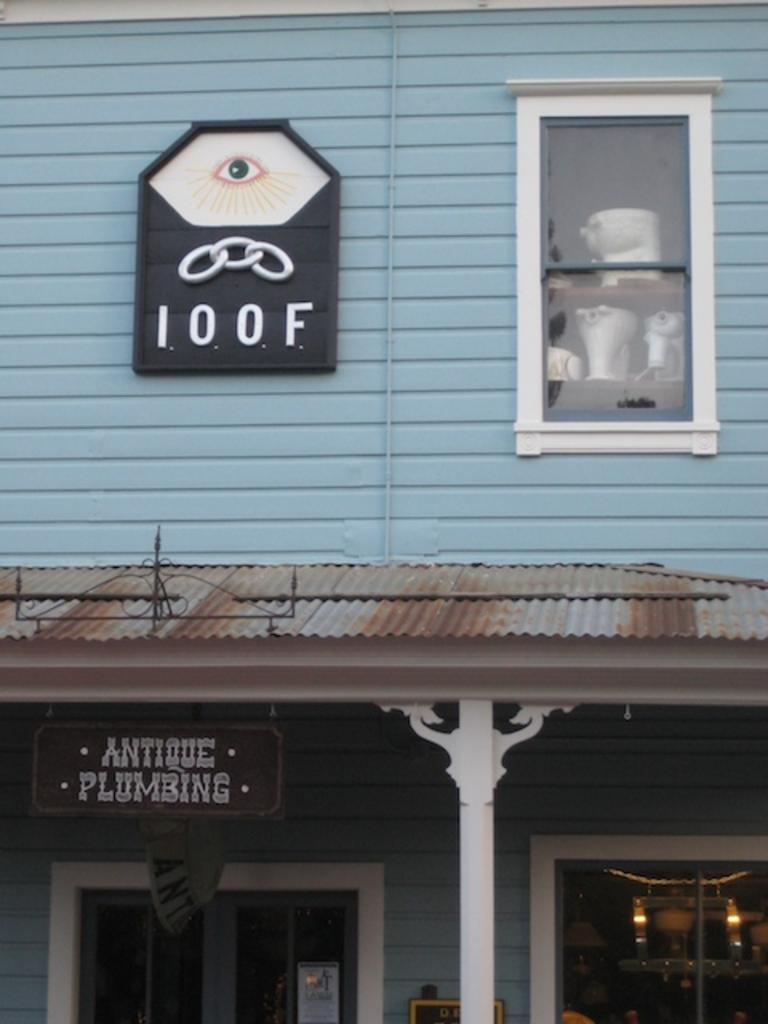<image>
Summarize the visual content of the image. Blue building with a black sign which says 100F. 